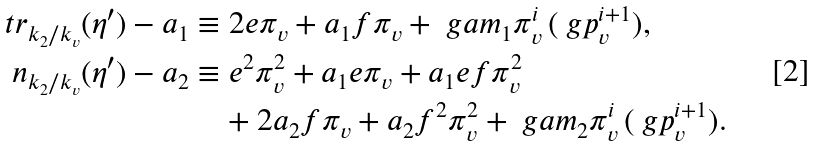<formula> <loc_0><loc_0><loc_500><loc_500>\ t r _ { k _ { 2 } / k _ { v } } ( \eta ^ { \prime } ) - a _ { 1 } & \equiv 2 e \pi _ { v } + a _ { 1 } f \pi _ { v } + \ g a m _ { 1 } \pi _ { v } ^ { i } \, ( \ g p _ { v } ^ { i + 1 } ) , \\ \ n _ { k _ { 2 } / k _ { v } } ( \eta ^ { \prime } ) - a _ { 2 } & \equiv e ^ { 2 } \pi _ { v } ^ { 2 } + a _ { 1 } e \pi _ { v } + a _ { 1 } e f \pi _ { v } ^ { 2 } \\ & \quad + 2 a _ { 2 } f \pi _ { v } + a _ { 2 } f ^ { 2 } \pi _ { v } ^ { 2 } + \ g a m _ { 2 } \pi _ { v } ^ { i } \, ( \ g p _ { v } ^ { i + 1 } ) .</formula> 